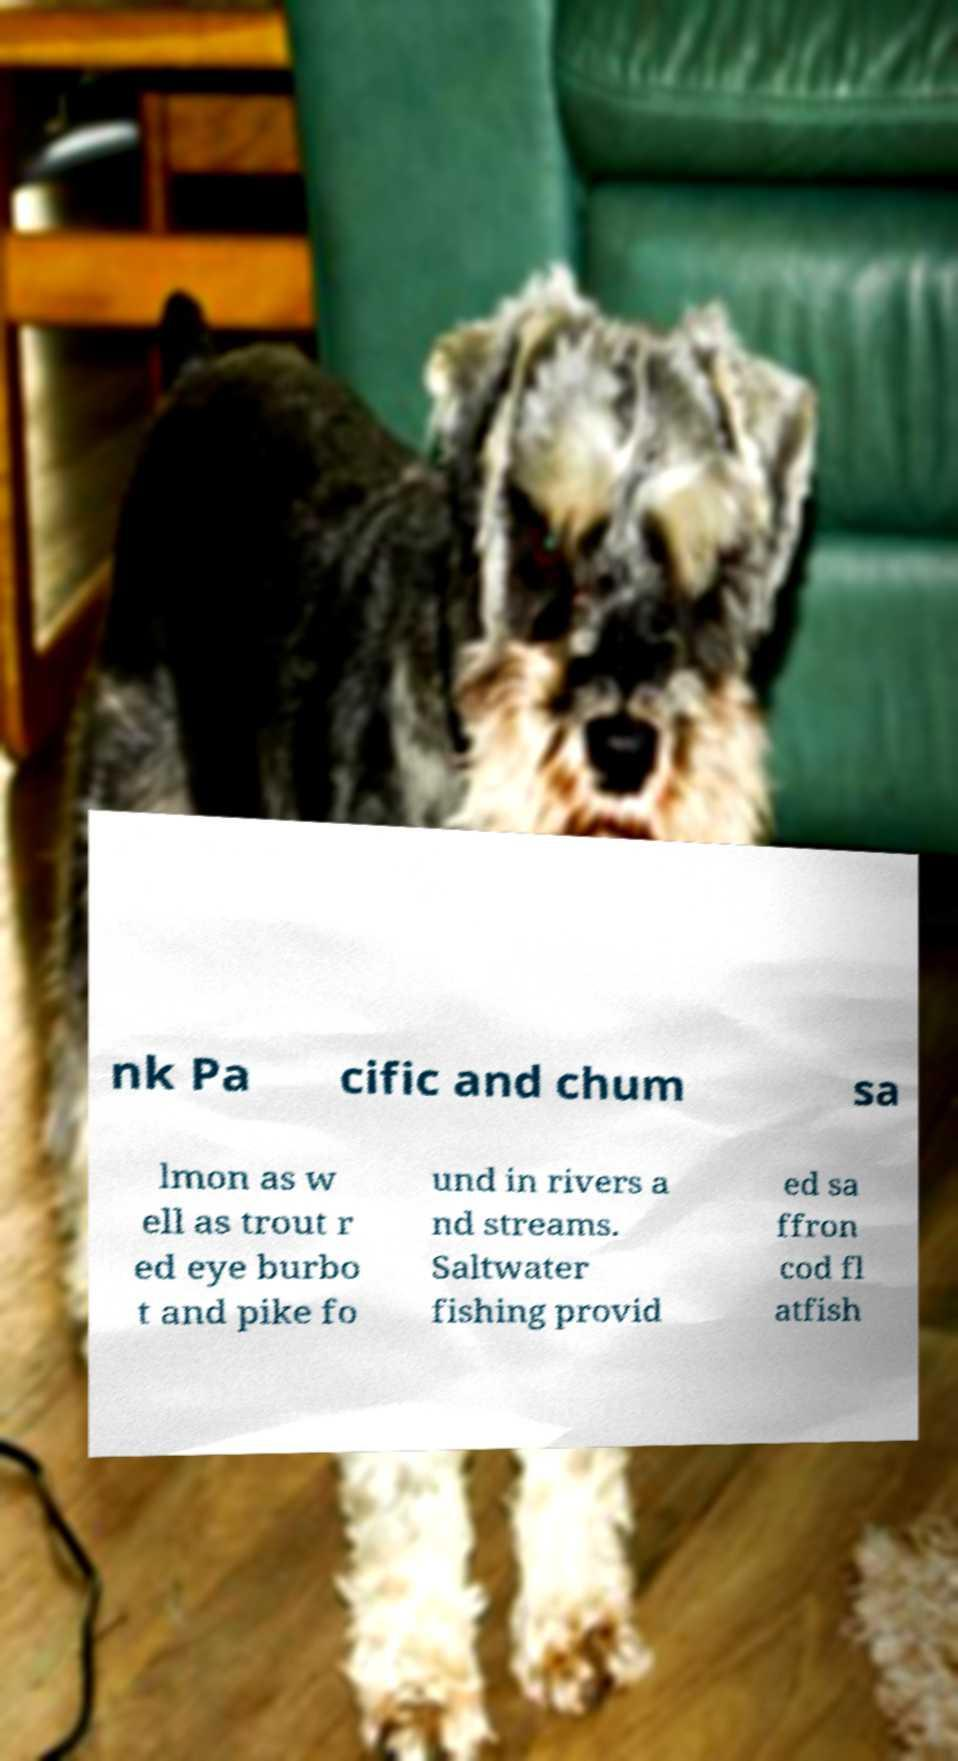There's text embedded in this image that I need extracted. Can you transcribe it verbatim? nk Pa cific and chum sa lmon as w ell as trout r ed eye burbo t and pike fo und in rivers a nd streams. Saltwater fishing provid ed sa ffron cod fl atfish 